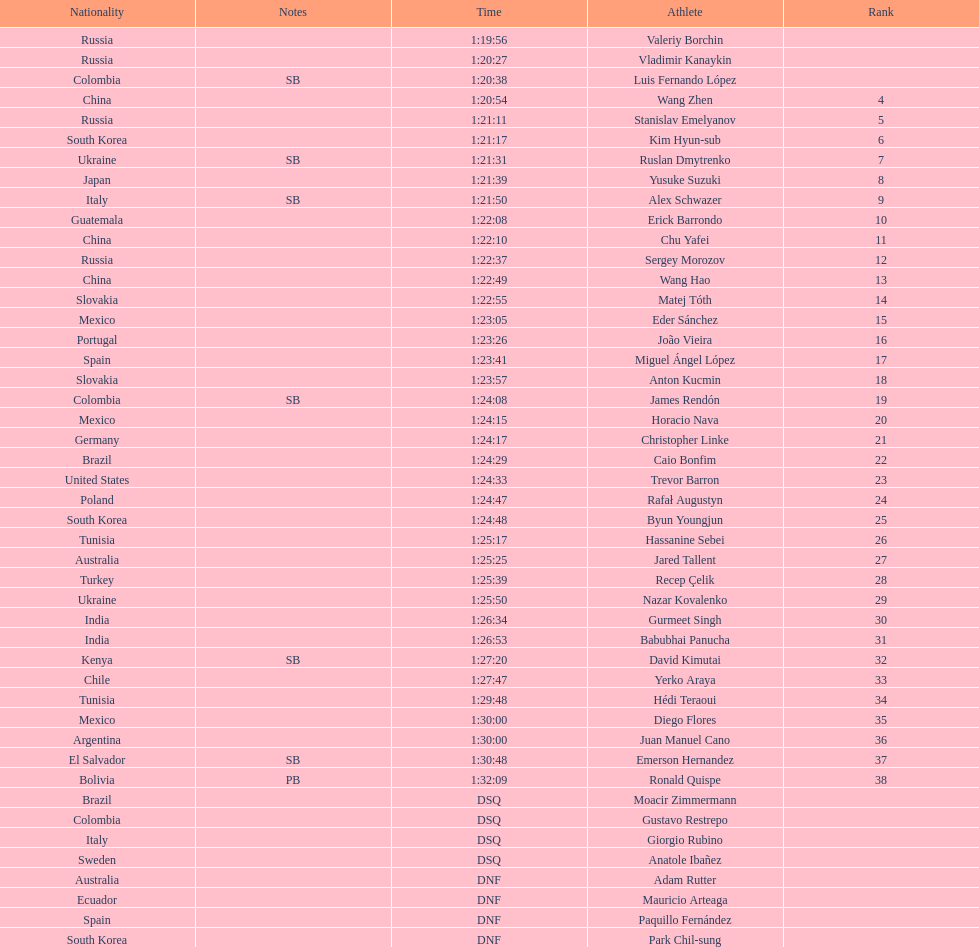Name all athletes were slower than horacio nava. Christopher Linke, Caio Bonfim, Trevor Barron, Rafał Augustyn, Byun Youngjun, Hassanine Sebei, Jared Tallent, Recep Çelik, Nazar Kovalenko, Gurmeet Singh, Babubhai Panucha, David Kimutai, Yerko Araya, Hédi Teraoui, Diego Flores, Juan Manuel Cano, Emerson Hernandez, Ronald Quispe. 